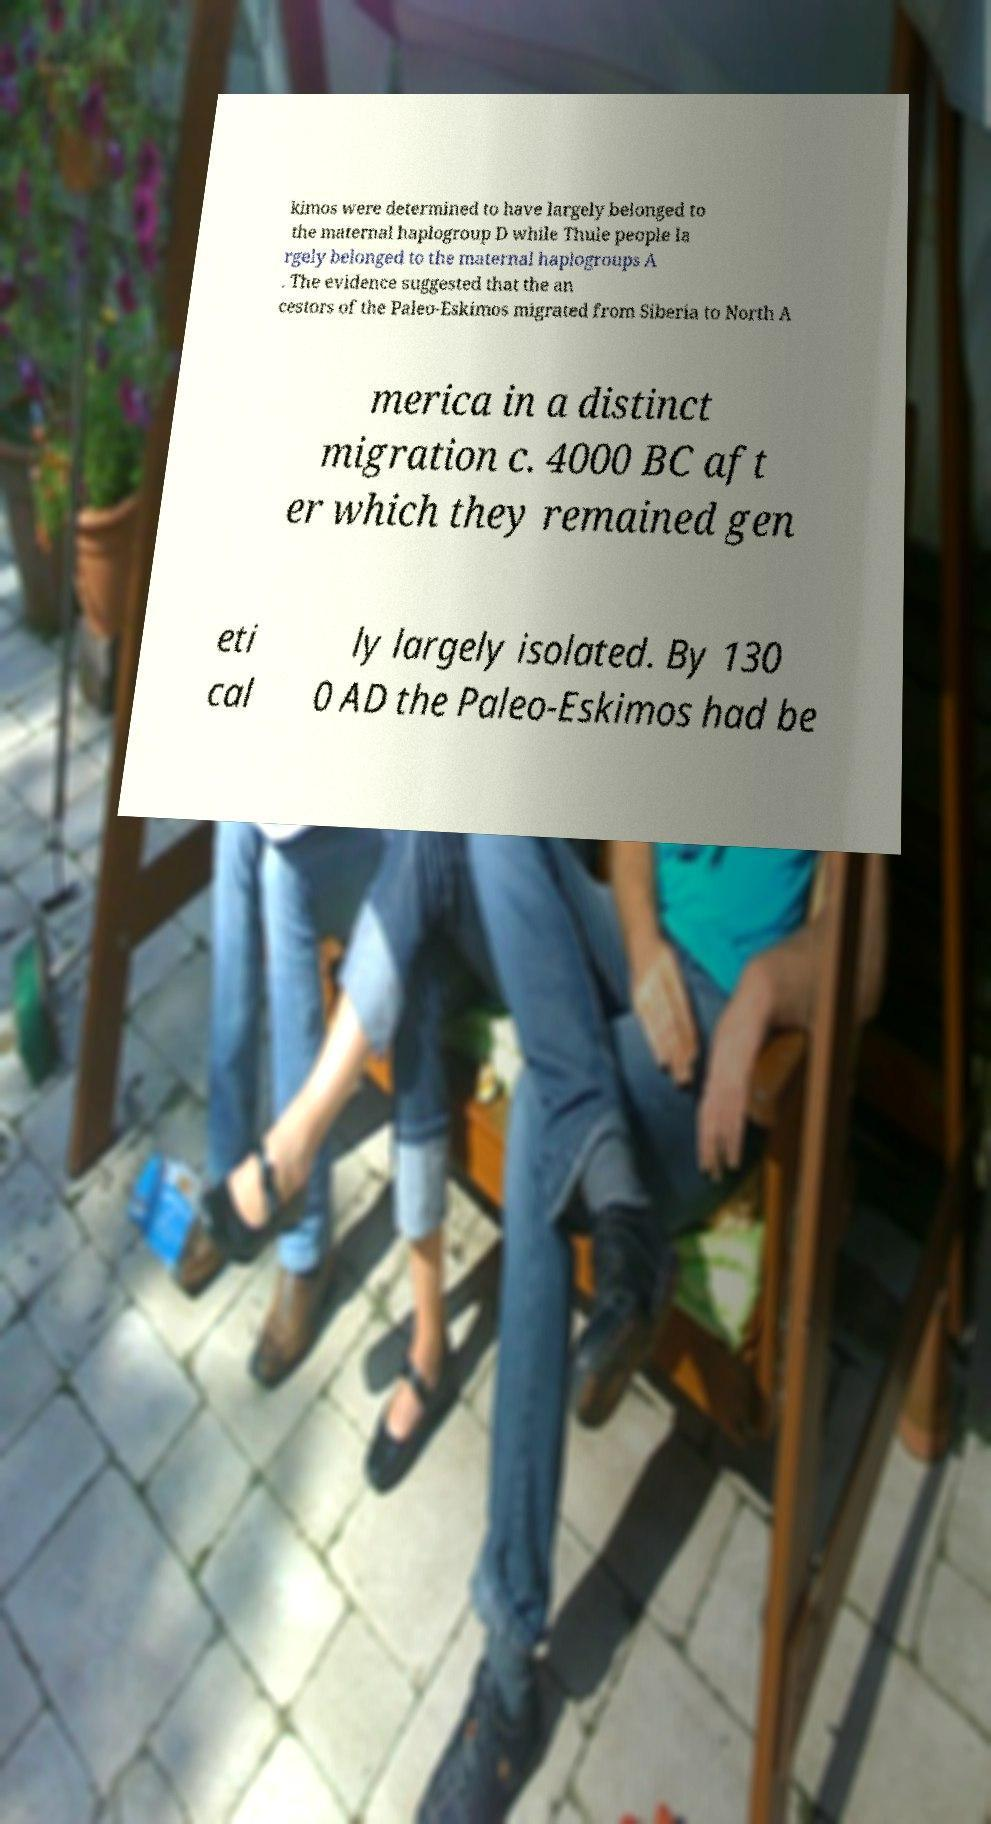I need the written content from this picture converted into text. Can you do that? kimos were determined to have largely belonged to the maternal haplogroup D while Thule people la rgely belonged to the maternal haplogroups A . The evidence suggested that the an cestors of the Paleo-Eskimos migrated from Siberia to North A merica in a distinct migration c. 4000 BC aft er which they remained gen eti cal ly largely isolated. By 130 0 AD the Paleo-Eskimos had be 